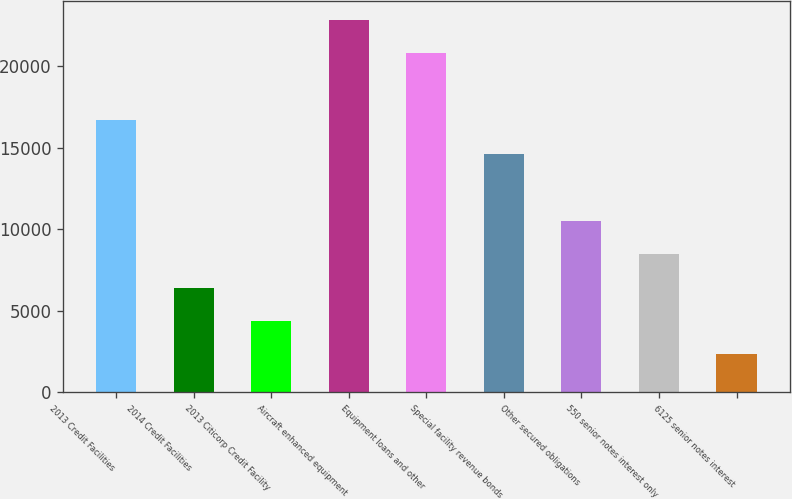Convert chart. <chart><loc_0><loc_0><loc_500><loc_500><bar_chart><fcel>2013 Credit Facilities<fcel>2014 Credit Facilities<fcel>2013 Citicorp Credit Facility<fcel>Aircraft enhanced equipment<fcel>Equipment loans and other<fcel>Special facility revenue bonds<fcel>Other secured obligations<fcel>550 senior notes interest only<fcel>6125 senior notes interest<nl><fcel>16694.8<fcel>6414.3<fcel>4358.2<fcel>22863.1<fcel>20807<fcel>14638.7<fcel>10526.5<fcel>8470.4<fcel>2302.1<nl></chart> 